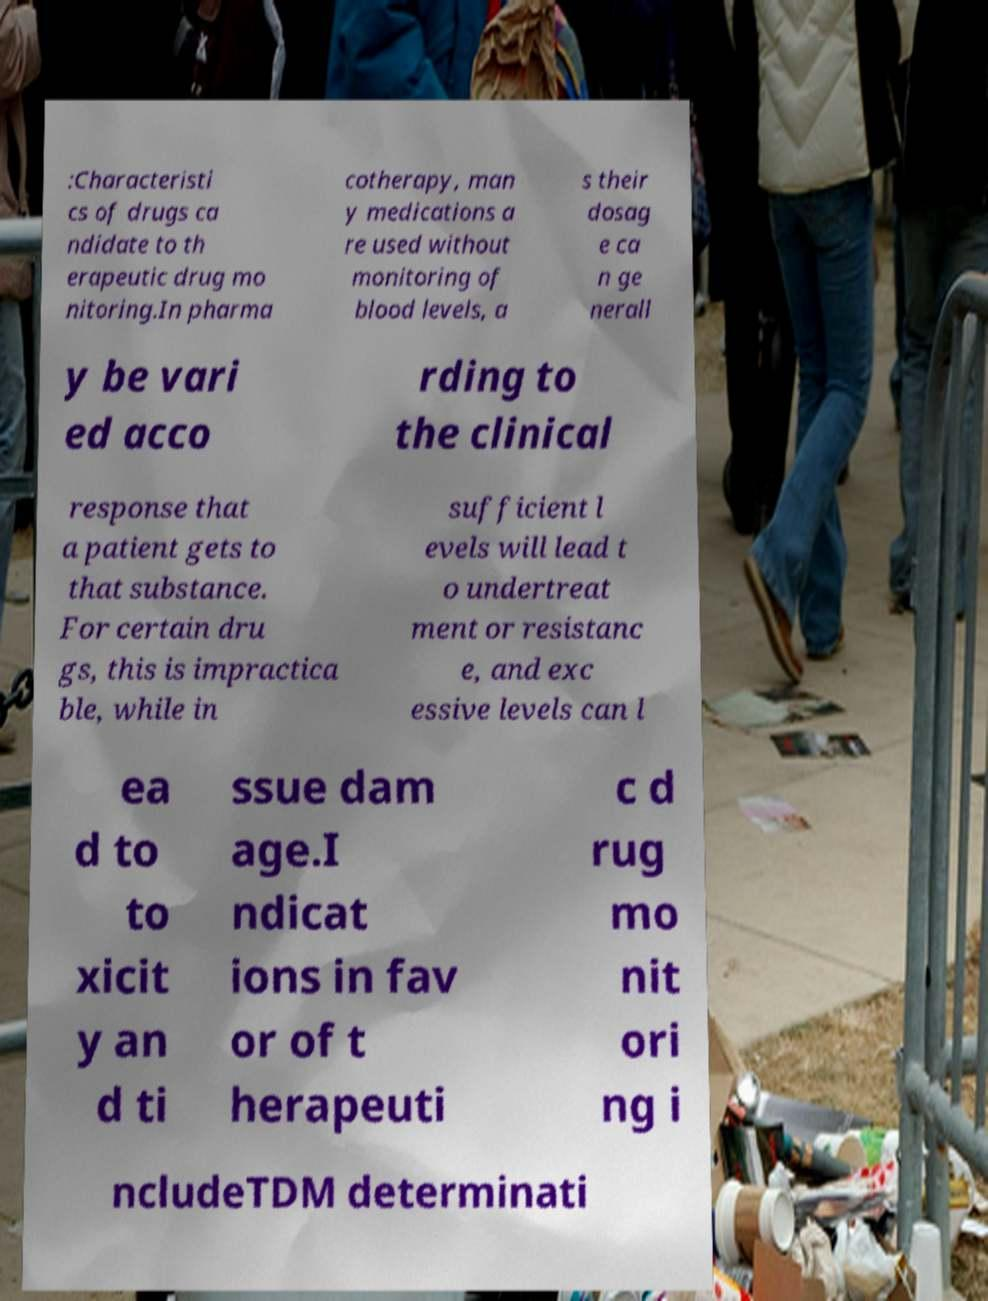Could you assist in decoding the text presented in this image and type it out clearly? :Characteristi cs of drugs ca ndidate to th erapeutic drug mo nitoring.In pharma cotherapy, man y medications a re used without monitoring of blood levels, a s their dosag e ca n ge nerall y be vari ed acco rding to the clinical response that a patient gets to that substance. For certain dru gs, this is impractica ble, while in sufficient l evels will lead t o undertreat ment or resistanc e, and exc essive levels can l ea d to to xicit y an d ti ssue dam age.I ndicat ions in fav or of t herapeuti c d rug mo nit ori ng i ncludeTDM determinati 